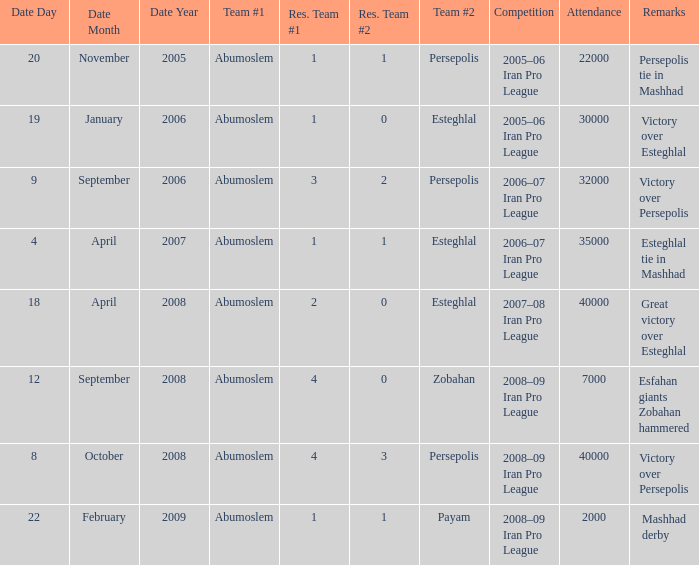What are the remarks for 8 October 2008? Victory over Persepolis. 